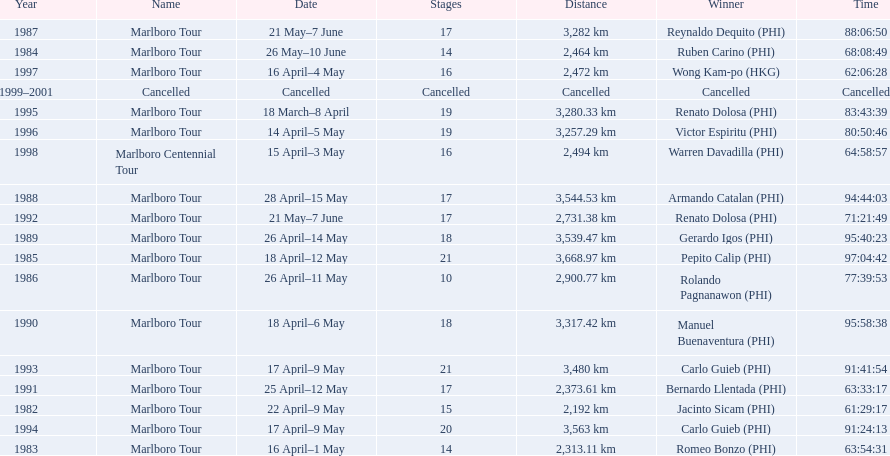Which year did warren davdilla (w.d.) appear? 1998. What tour did w.d. complete? Marlboro Centennial Tour. What is the time recorded in the same row as w.d.? 64:58:57. 